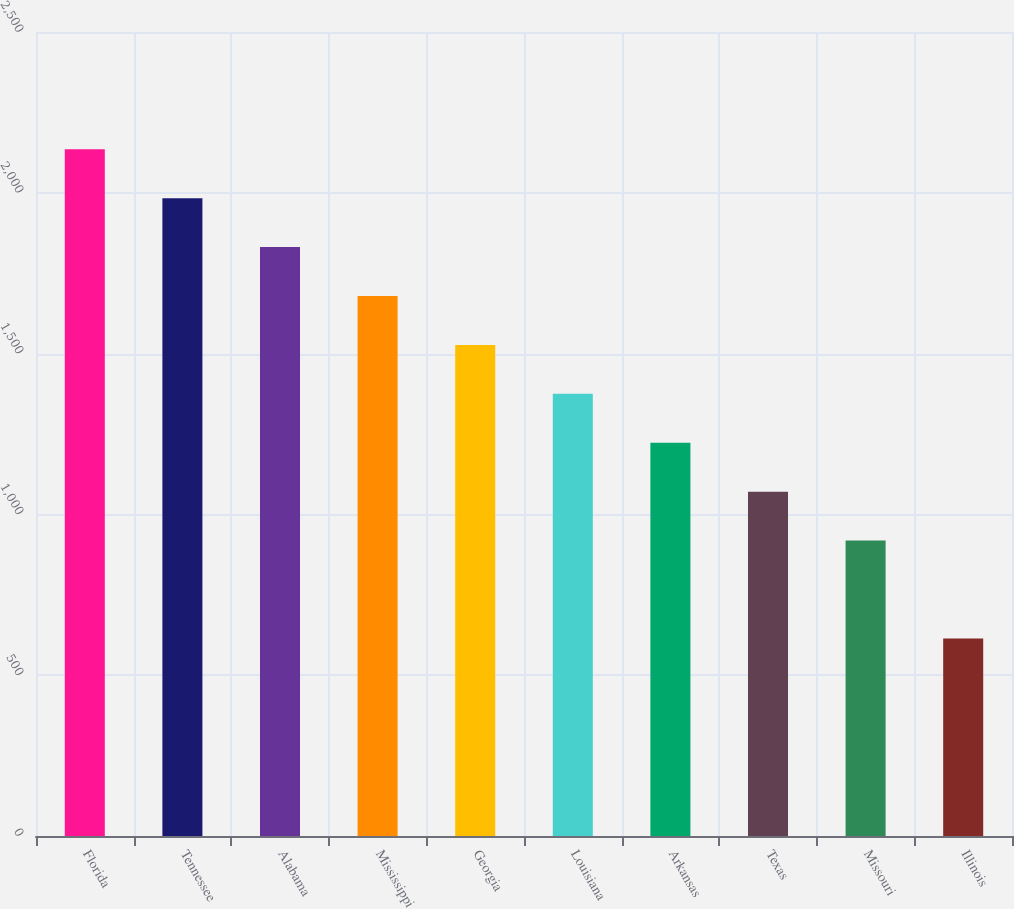<chart> <loc_0><loc_0><loc_500><loc_500><bar_chart><fcel>Florida<fcel>Tennessee<fcel>Alabama<fcel>Mississippi<fcel>Georgia<fcel>Louisiana<fcel>Arkansas<fcel>Texas<fcel>Missouri<fcel>Illinois<nl><fcel>2135.4<fcel>1983.3<fcel>1831.2<fcel>1679.1<fcel>1527<fcel>1374.9<fcel>1222.8<fcel>1070.7<fcel>918.6<fcel>614.4<nl></chart> 